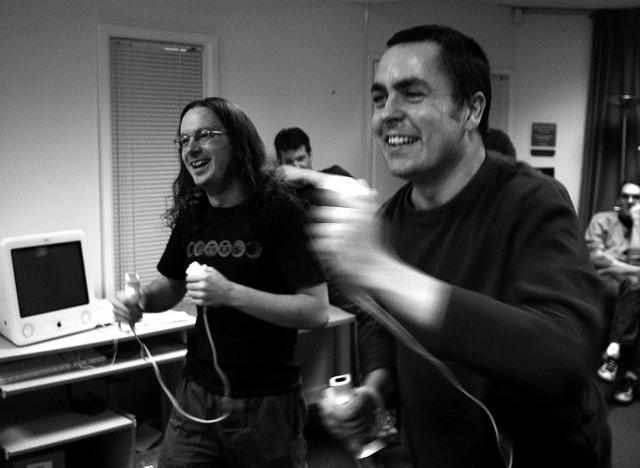What should be installed on the device with a screen?
Pick the right solution, then justify: 'Answer: answer
Rationale: rationale.'
Options: Operating system, oil line, vice, heater. Answer: operating system.
Rationale: An os should be installed. 